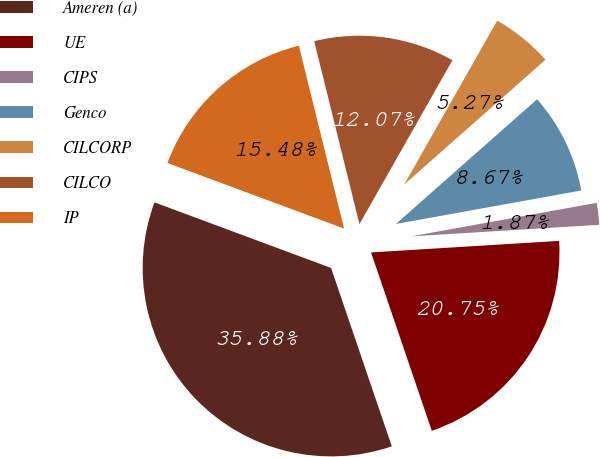Convert chart to OTSL. <chart><loc_0><loc_0><loc_500><loc_500><pie_chart><fcel>Ameren (a)<fcel>UE<fcel>CIPS<fcel>Genco<fcel>CILCORP<fcel>CILCO<fcel>IP<nl><fcel>35.88%<fcel>20.75%<fcel>1.87%<fcel>8.67%<fcel>5.27%<fcel>12.07%<fcel>15.48%<nl></chart> 